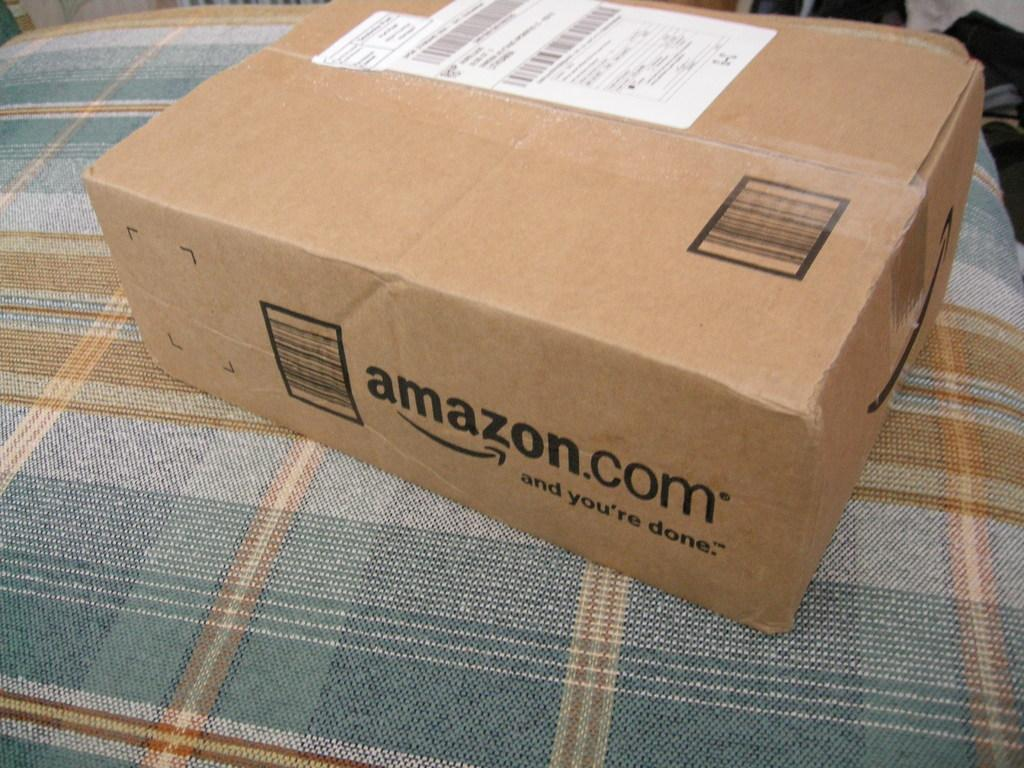<image>
Offer a succinct explanation of the picture presented. a box from Amazon.com on a plaid bed spread 